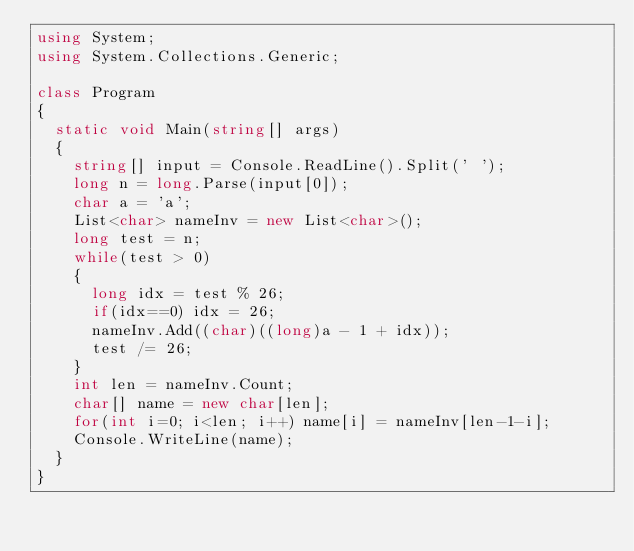<code> <loc_0><loc_0><loc_500><loc_500><_C#_>using System;
using System.Collections.Generic;

class Program
{
	static void Main(string[] args)
	{
		string[] input = Console.ReadLine().Split(' ');
		long n = long.Parse(input[0]);
		char a = 'a';
		List<char> nameInv = new List<char>();
		long test = n;
		while(test > 0)
		{
			long idx = test % 26;
			if(idx==0) idx = 26;
			nameInv.Add((char)((long)a - 1 + idx));
			test /= 26;
		}
		int len = nameInv.Count;
		char[] name = new char[len];
		for(int i=0; i<len; i++) name[i] = nameInv[len-1-i];
		Console.WriteLine(name);
	}
}
</code> 